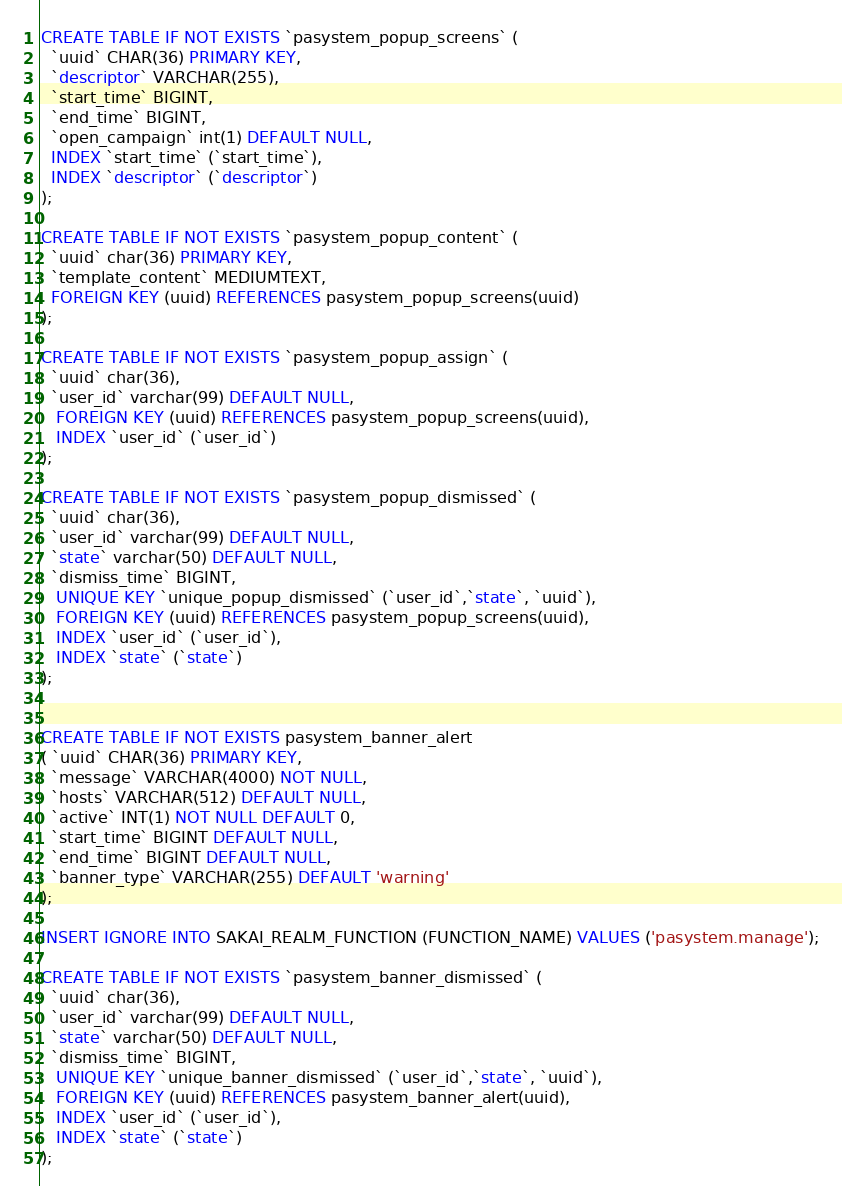<code> <loc_0><loc_0><loc_500><loc_500><_SQL_>CREATE TABLE IF NOT EXISTS `pasystem_popup_screens` (
  `uuid` CHAR(36) PRIMARY KEY,
  `descriptor` VARCHAR(255),
  `start_time` BIGINT,
  `end_time` BIGINT,
  `open_campaign` int(1) DEFAULT NULL,
  INDEX `start_time` (`start_time`),
  INDEX `descriptor` (`descriptor`)
);

CREATE TABLE IF NOT EXISTS `pasystem_popup_content` (
  `uuid` char(36) PRIMARY KEY,
  `template_content` MEDIUMTEXT,
  FOREIGN KEY (uuid) REFERENCES pasystem_popup_screens(uuid)
);

CREATE TABLE IF NOT EXISTS `pasystem_popup_assign` (
  `uuid` char(36),
  `user_id` varchar(99) DEFAULT NULL,
   FOREIGN KEY (uuid) REFERENCES pasystem_popup_screens(uuid),
   INDEX `user_id` (`user_id`)
);

CREATE TABLE IF NOT EXISTS `pasystem_popup_dismissed` (
  `uuid` char(36),
  `user_id` varchar(99) DEFAULT NULL,
  `state` varchar(50) DEFAULT NULL,
  `dismiss_time` BIGINT,
   UNIQUE KEY `unique_popup_dismissed` (`user_id`,`state`, `uuid`),
   FOREIGN KEY (uuid) REFERENCES pasystem_popup_screens(uuid),
   INDEX `user_id` (`user_id`),
   INDEX `state` (`state`)
);


CREATE TABLE IF NOT EXISTS pasystem_banner_alert
( `uuid` CHAR(36) PRIMARY KEY,
  `message` VARCHAR(4000) NOT NULL,
  `hosts` VARCHAR(512) DEFAULT NULL,
  `active` INT(1) NOT NULL DEFAULT 0,
  `start_time` BIGINT DEFAULT NULL,
  `end_time` BIGINT DEFAULT NULL,
  `banner_type` VARCHAR(255) DEFAULT 'warning'
);

INSERT IGNORE INTO SAKAI_REALM_FUNCTION (FUNCTION_NAME) VALUES ('pasystem.manage');

CREATE TABLE IF NOT EXISTS `pasystem_banner_dismissed` (
  `uuid` char(36),
  `user_id` varchar(99) DEFAULT NULL,
  `state` varchar(50) DEFAULT NULL,
  `dismiss_time` BIGINT,
   UNIQUE KEY `unique_banner_dismissed` (`user_id`,`state`, `uuid`),
   FOREIGN KEY (uuid) REFERENCES pasystem_banner_alert(uuid),
   INDEX `user_id` (`user_id`),
   INDEX `state` (`state`)
);

</code> 